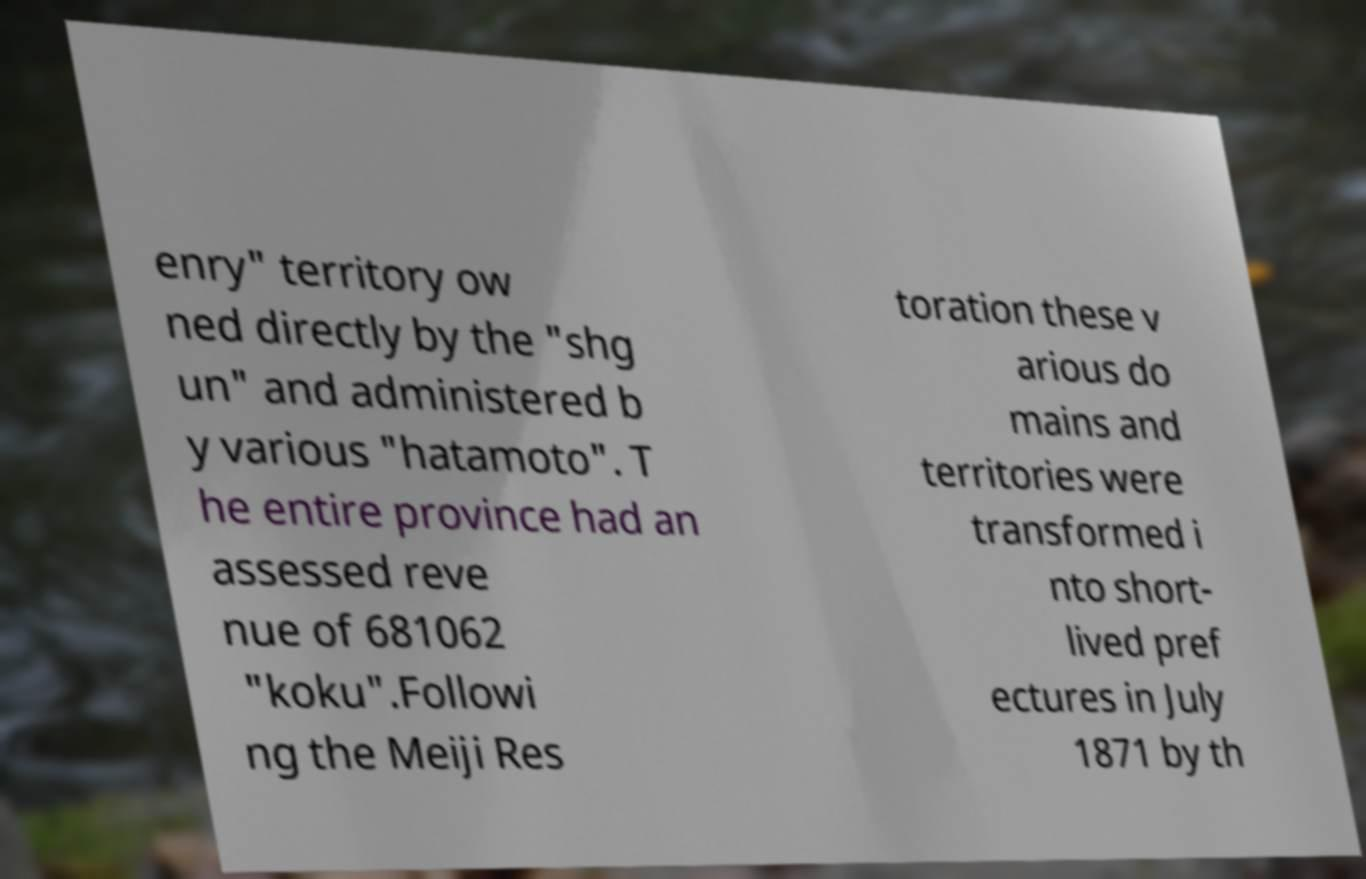Could you assist in decoding the text presented in this image and type it out clearly? enry" territory ow ned directly by the "shg un" and administered b y various "hatamoto". T he entire province had an assessed reve nue of 681062 "koku".Followi ng the Meiji Res toration these v arious do mains and territories were transformed i nto short- lived pref ectures in July 1871 by th 